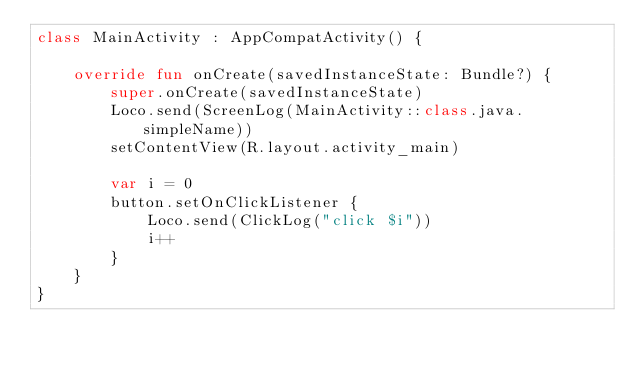Convert code to text. <code><loc_0><loc_0><loc_500><loc_500><_Kotlin_>class MainActivity : AppCompatActivity() {

    override fun onCreate(savedInstanceState: Bundle?) {
        super.onCreate(savedInstanceState)
        Loco.send(ScreenLog(MainActivity::class.java.simpleName))
        setContentView(R.layout.activity_main)

        var i = 0
        button.setOnClickListener {
            Loco.send(ClickLog("click $i"))
            i++
        }
    }
}
</code> 